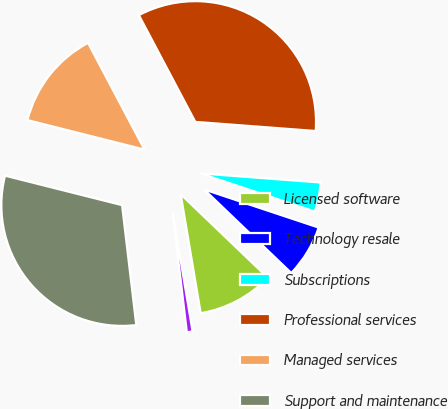Convert chart to OTSL. <chart><loc_0><loc_0><loc_500><loc_500><pie_chart><fcel>Licensed software<fcel>Technology resale<fcel>Subscriptions<fcel>Professional services<fcel>Managed services<fcel>Support and maintenance<fcel>Reimbursed travel<nl><fcel>10.19%<fcel>7.05%<fcel>3.91%<fcel>33.95%<fcel>13.33%<fcel>30.81%<fcel>0.77%<nl></chart> 